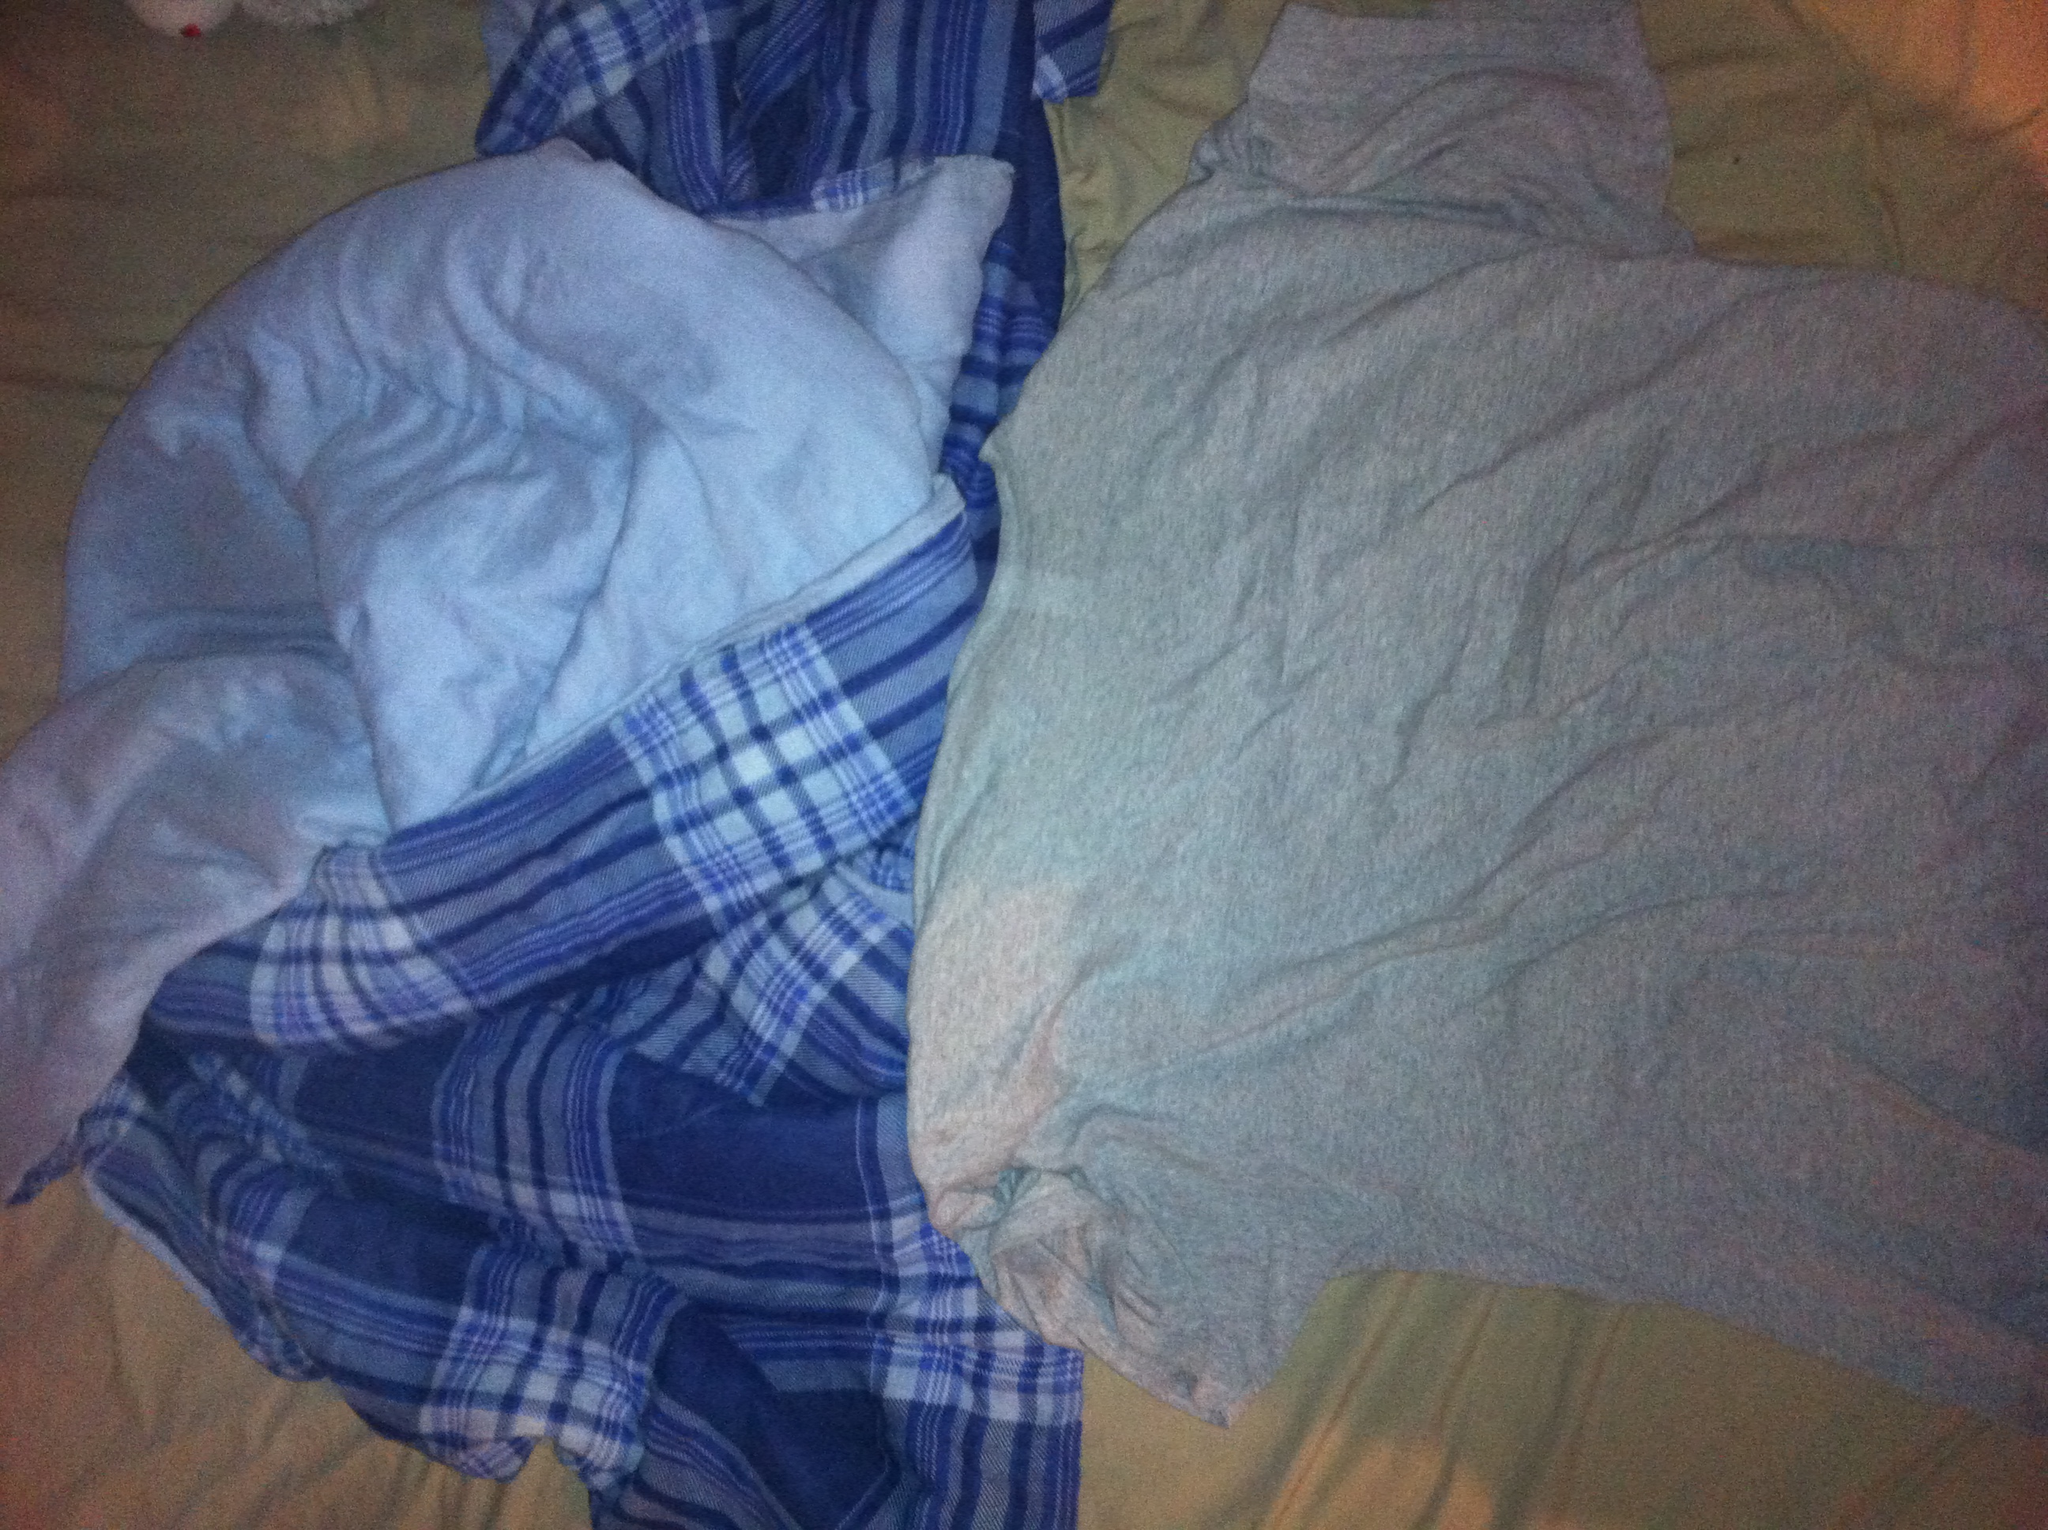What color is that shirt? The shirt is a light grey color, which is a neutral and versatile hue commonly found in casual clothing. 